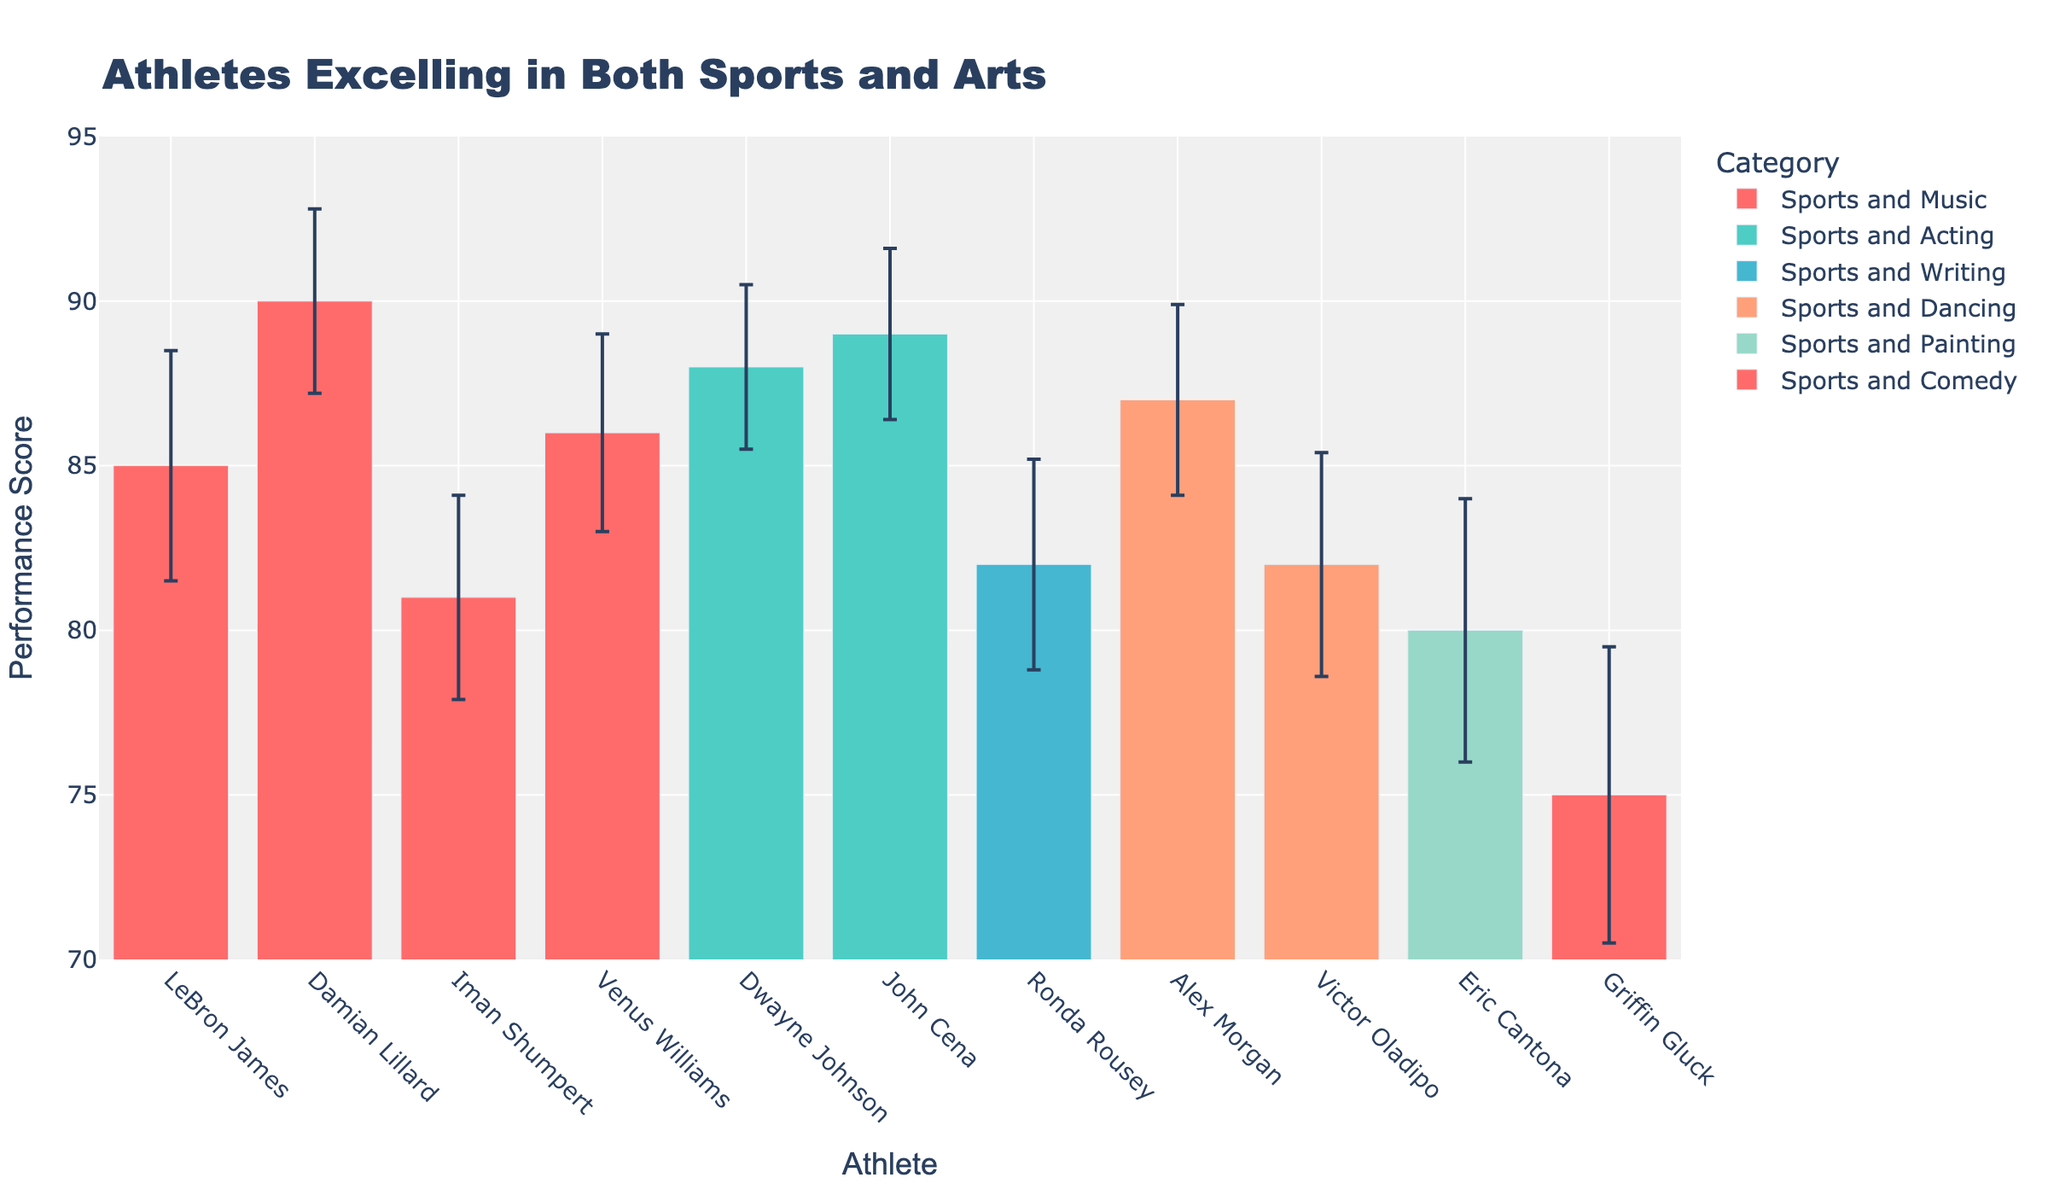What's the title of the plot? The title is located at the top center of the plot and provides a summary of the visualized data.
Answer: Athletes Excelling in Both Sports and Arts Which athlete has the highest performance score? Look for the tallest bar in the plot across all categories.
Answer: Damian Lillard What are the categories listed in the legend? The categories are color-coded and listed in the legend on the right side of the plot.
Answer: Sports and Music, Sports and Acting, Sports and Writing, Sports and Dancing, Sports and Painting, Sports and Comedy What is the performance score and error for John Cena? Locate John Cena in the 'Sports and Acting' category and note the height of his bar and the error bar value.
Answer: 89, ±2.6 Which category has the athlete with the lowest performance score? Identify the shortest bar across all the categories and note which category it falls under.
Answer: Sports and Comedy What is the average performance score of athletes in 'Sports and Music'? Find the performance scores of LeBron James, Damian Lillard, Iman Shumpert, and Venus Williams. Add these scores and then divide by 4. Calculation: (85 + 90 + 81 + 86) / 4 = 85.5
Answer: 85.5 Who has the largest error in their performance score, and what is the value? Locate the bar with the error bar that extends the furthest.
Answer: Griffin Gluck, ±4.5 Compare the performance scores of 'Sports and Acting' athletes. Which one scores higher? Compare the heights of the bars for Dwayne Johnson and John Cena within the 'Sports and Acting' category.
Answer: John Cena What's the combined performance score of 'Sports and Dancing' athletes? Add the performance scores of Alex Morgan and Victor Oladipo. Calculation: 87 + 82 = 169
Answer: 169 Who has a higher performance score, Ronda Rousey or Eric Cantona, and by how much? Compare the performance scores of Ronda Rousey (Sports and Writing) and Eric Cantona (Sports and Painting). Calculation: 82 - 80 = 2
Answer: Ronda Rousey by 2 